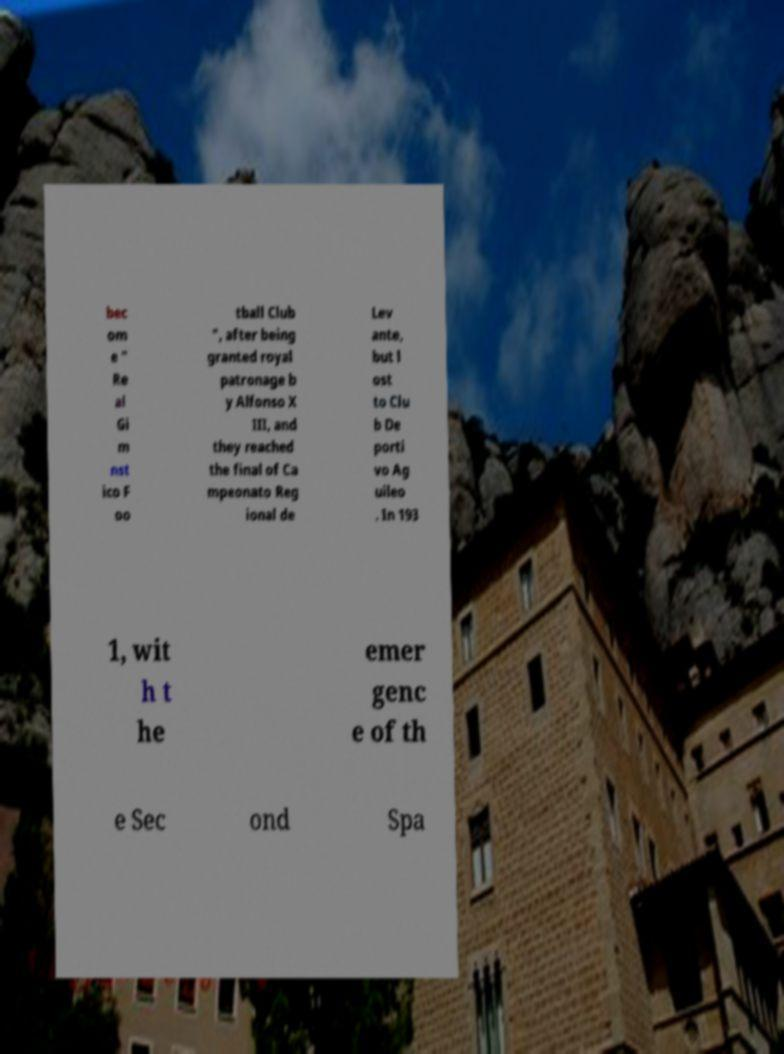Please read and relay the text visible in this image. What does it say? bec om e " Re al Gi m nst ico F oo tball Club ", after being granted royal patronage b y Alfonso X III, and they reached the final of Ca mpeonato Reg ional de Lev ante, but l ost to Clu b De porti vo Ag uileo . In 193 1, wit h t he emer genc e of th e Sec ond Spa 